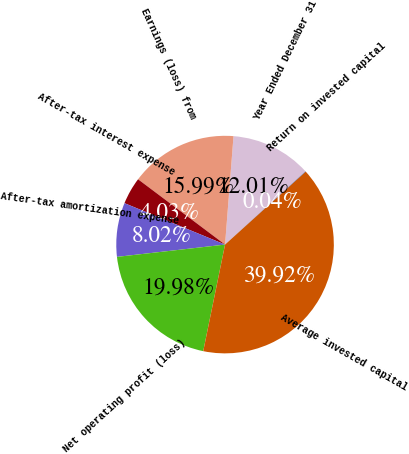<chart> <loc_0><loc_0><loc_500><loc_500><pie_chart><fcel>Year Ended December 31<fcel>Earnings (loss) from<fcel>After-tax interest expense<fcel>After-tax amortization expense<fcel>Net operating profit (loss)<fcel>Average invested capital<fcel>Return on invested capital<nl><fcel>12.01%<fcel>15.99%<fcel>4.03%<fcel>8.02%<fcel>19.98%<fcel>39.92%<fcel>0.04%<nl></chart> 